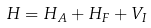<formula> <loc_0><loc_0><loc_500><loc_500>H = H _ { A } + H _ { F } + V _ { I }</formula> 